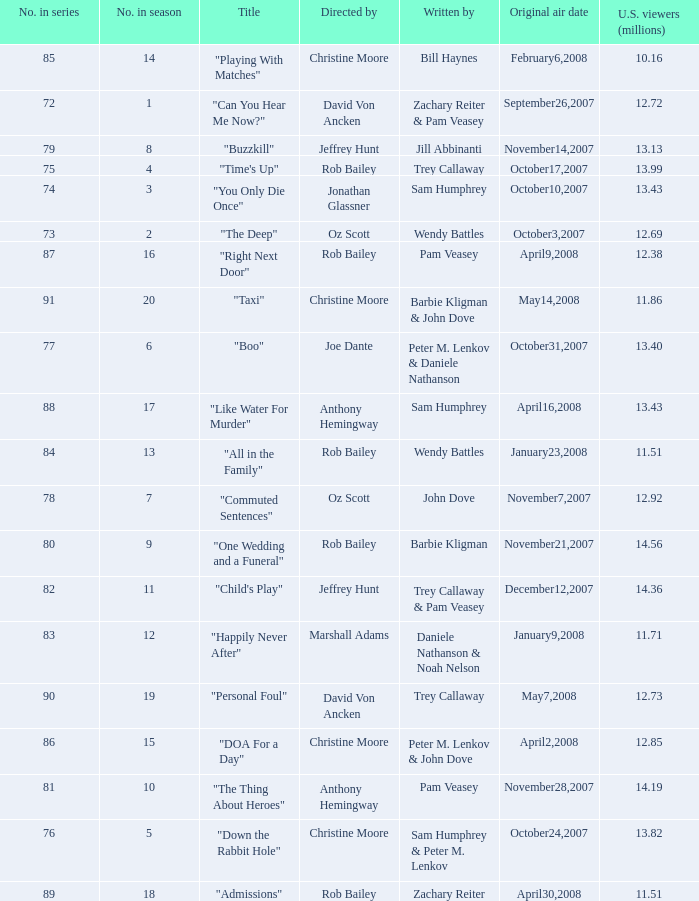How many millions of U.S. viewers watched the episode "Buzzkill"?  1.0. 